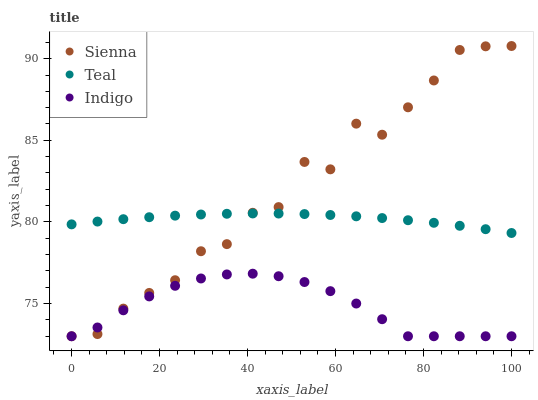Does Indigo have the minimum area under the curve?
Answer yes or no. Yes. Does Sienna have the maximum area under the curve?
Answer yes or no. Yes. Does Teal have the minimum area under the curve?
Answer yes or no. No. Does Teal have the maximum area under the curve?
Answer yes or no. No. Is Teal the smoothest?
Answer yes or no. Yes. Is Sienna the roughest?
Answer yes or no. Yes. Is Indigo the smoothest?
Answer yes or no. No. Is Indigo the roughest?
Answer yes or no. No. Does Sienna have the lowest value?
Answer yes or no. Yes. Does Teal have the lowest value?
Answer yes or no. No. Does Sienna have the highest value?
Answer yes or no. Yes. Does Teal have the highest value?
Answer yes or no. No. Is Indigo less than Teal?
Answer yes or no. Yes. Is Teal greater than Indigo?
Answer yes or no. Yes. Does Sienna intersect Teal?
Answer yes or no. Yes. Is Sienna less than Teal?
Answer yes or no. No. Is Sienna greater than Teal?
Answer yes or no. No. Does Indigo intersect Teal?
Answer yes or no. No. 